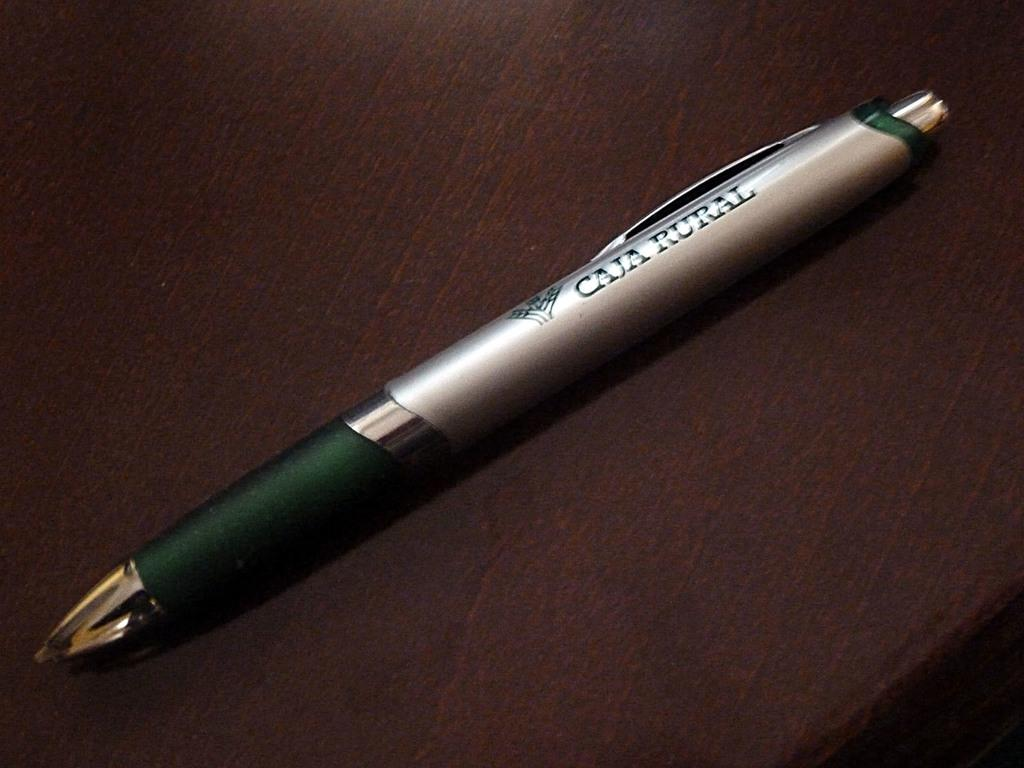What type of writing instrument is in the image? There is a gray color pen in the image. Where is the pen located? The pen is on a surface. What color is the background of the image? The background of the image is brown in color. How many kittens are playing with the calculator in the image? There is no calculator or kittens present in the image. 